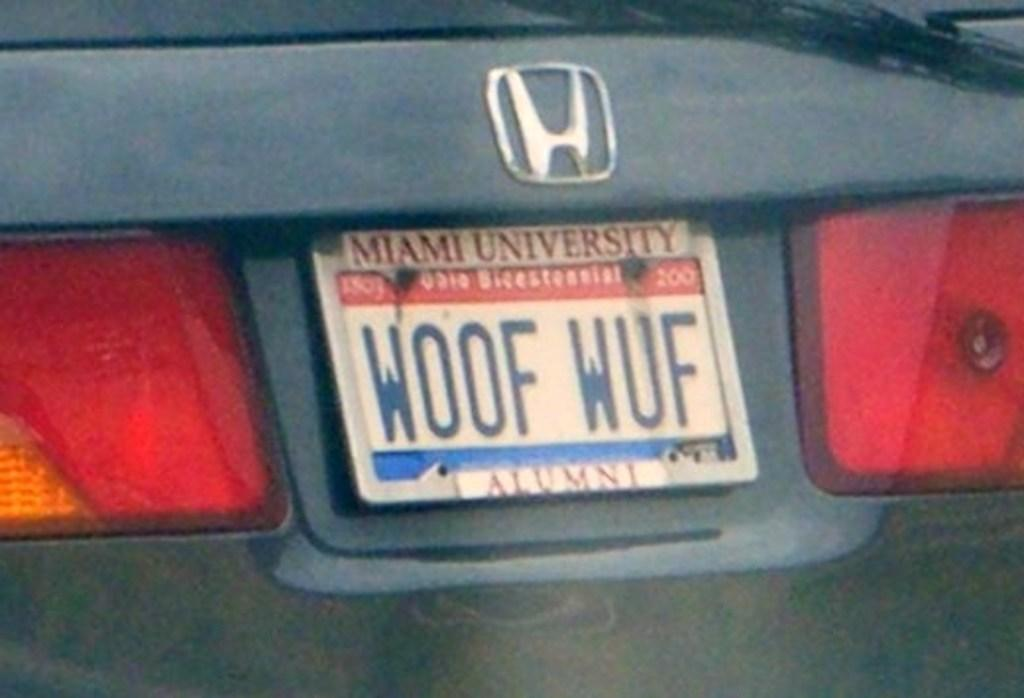<image>
Provide a brief description of the given image. The rear of a Honda with a license plate holder from Miami University. 